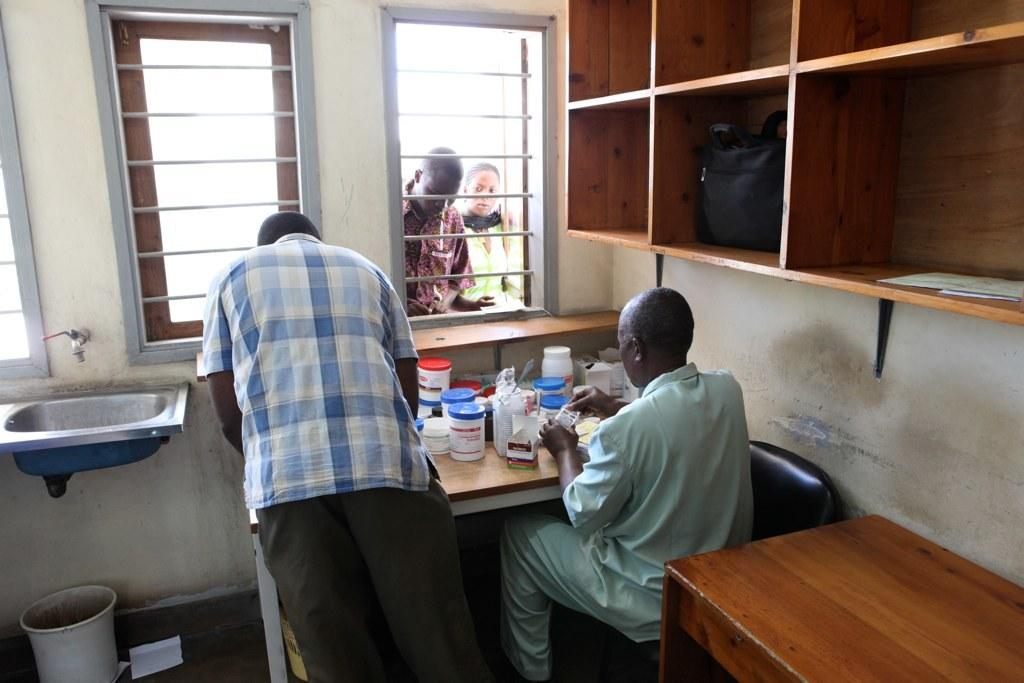How many people are present in the image? There are four people in the image. What can be seen to the right of the people? There is a cupboard to the right. What is inside the cupboard? There is a bag inside the cupboard. What is located to the left of the people? There is a sink to the left. What objects are on the table? There are containers on the table. What type of debt is being discussed by the people in the image? There is no indication of any debt being discussed in the image. What board is being used by the people in the image? There is no board present in the image. 